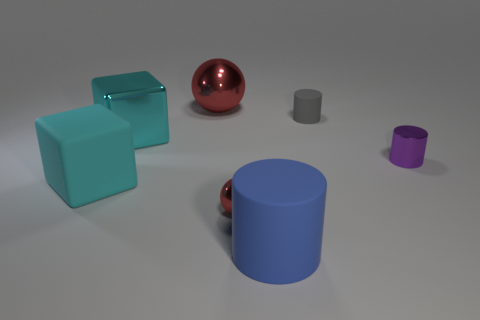Subtract all blue matte cylinders. How many cylinders are left? 2 Add 1 metal cylinders. How many objects exist? 8 Subtract all blue cylinders. How many cylinders are left? 2 Subtract all spheres. How many objects are left? 5 Subtract 1 spheres. How many spheres are left? 1 Subtract all brown cubes. How many blue cylinders are left? 1 Subtract all blue rubber cylinders. Subtract all big blue cylinders. How many objects are left? 5 Add 2 cyan shiny things. How many cyan shiny things are left? 3 Add 7 cyan shiny blocks. How many cyan shiny blocks exist? 8 Subtract 0 brown blocks. How many objects are left? 7 